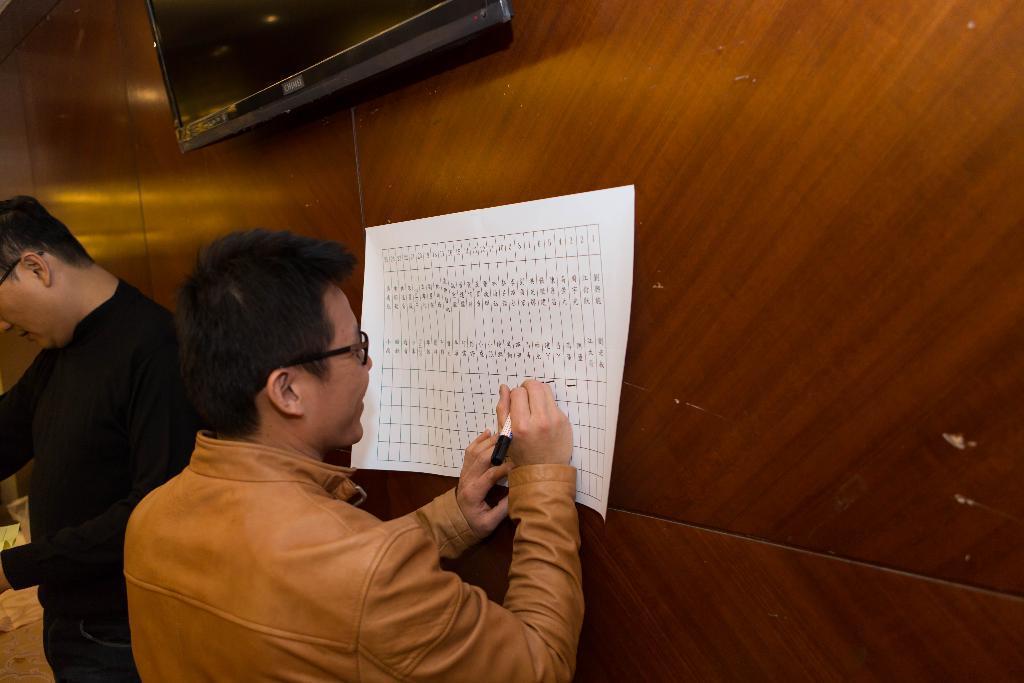Please provide a concise description of this image. In this image I can see two people standing one person is holding a paper and writing something on that paper and at the top of image I can see a monitor with a wooden background. 